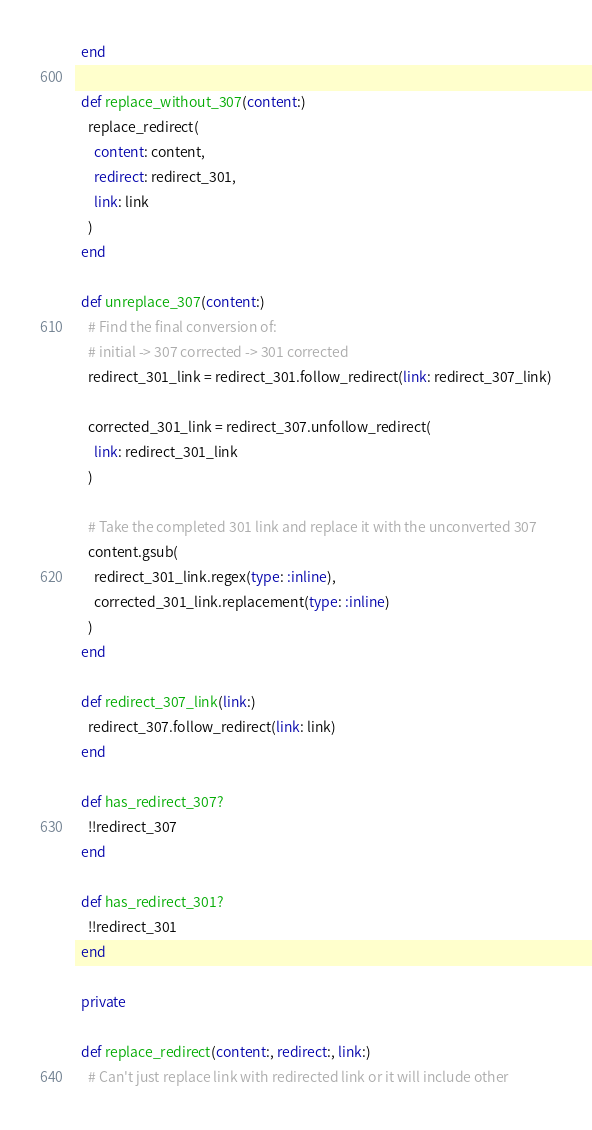<code> <loc_0><loc_0><loc_500><loc_500><_Ruby_>  end

  def replace_without_307(content:)
    replace_redirect(
      content: content,
      redirect: redirect_301,
      link: link
    )
  end

  def unreplace_307(content:)
    # Find the final conversion of:
    # initial -> 307 corrected -> 301 corrected
    redirect_301_link = redirect_301.follow_redirect(link: redirect_307_link)

    corrected_301_link = redirect_307.unfollow_redirect(
      link: redirect_301_link
    )

    # Take the completed 301 link and replace it with the unconverted 307
    content.gsub(
      redirect_301_link.regex(type: :inline),
      corrected_301_link.replacement(type: :inline)
    )
  end

  def redirect_307_link(link:)
    redirect_307.follow_redirect(link: link)
  end

  def has_redirect_307?
    !!redirect_307
  end

  def has_redirect_301?
    !!redirect_301
  end

  private

  def replace_redirect(content:, redirect:, link:)
    # Can't just replace link with redirected link or it will include other</code> 